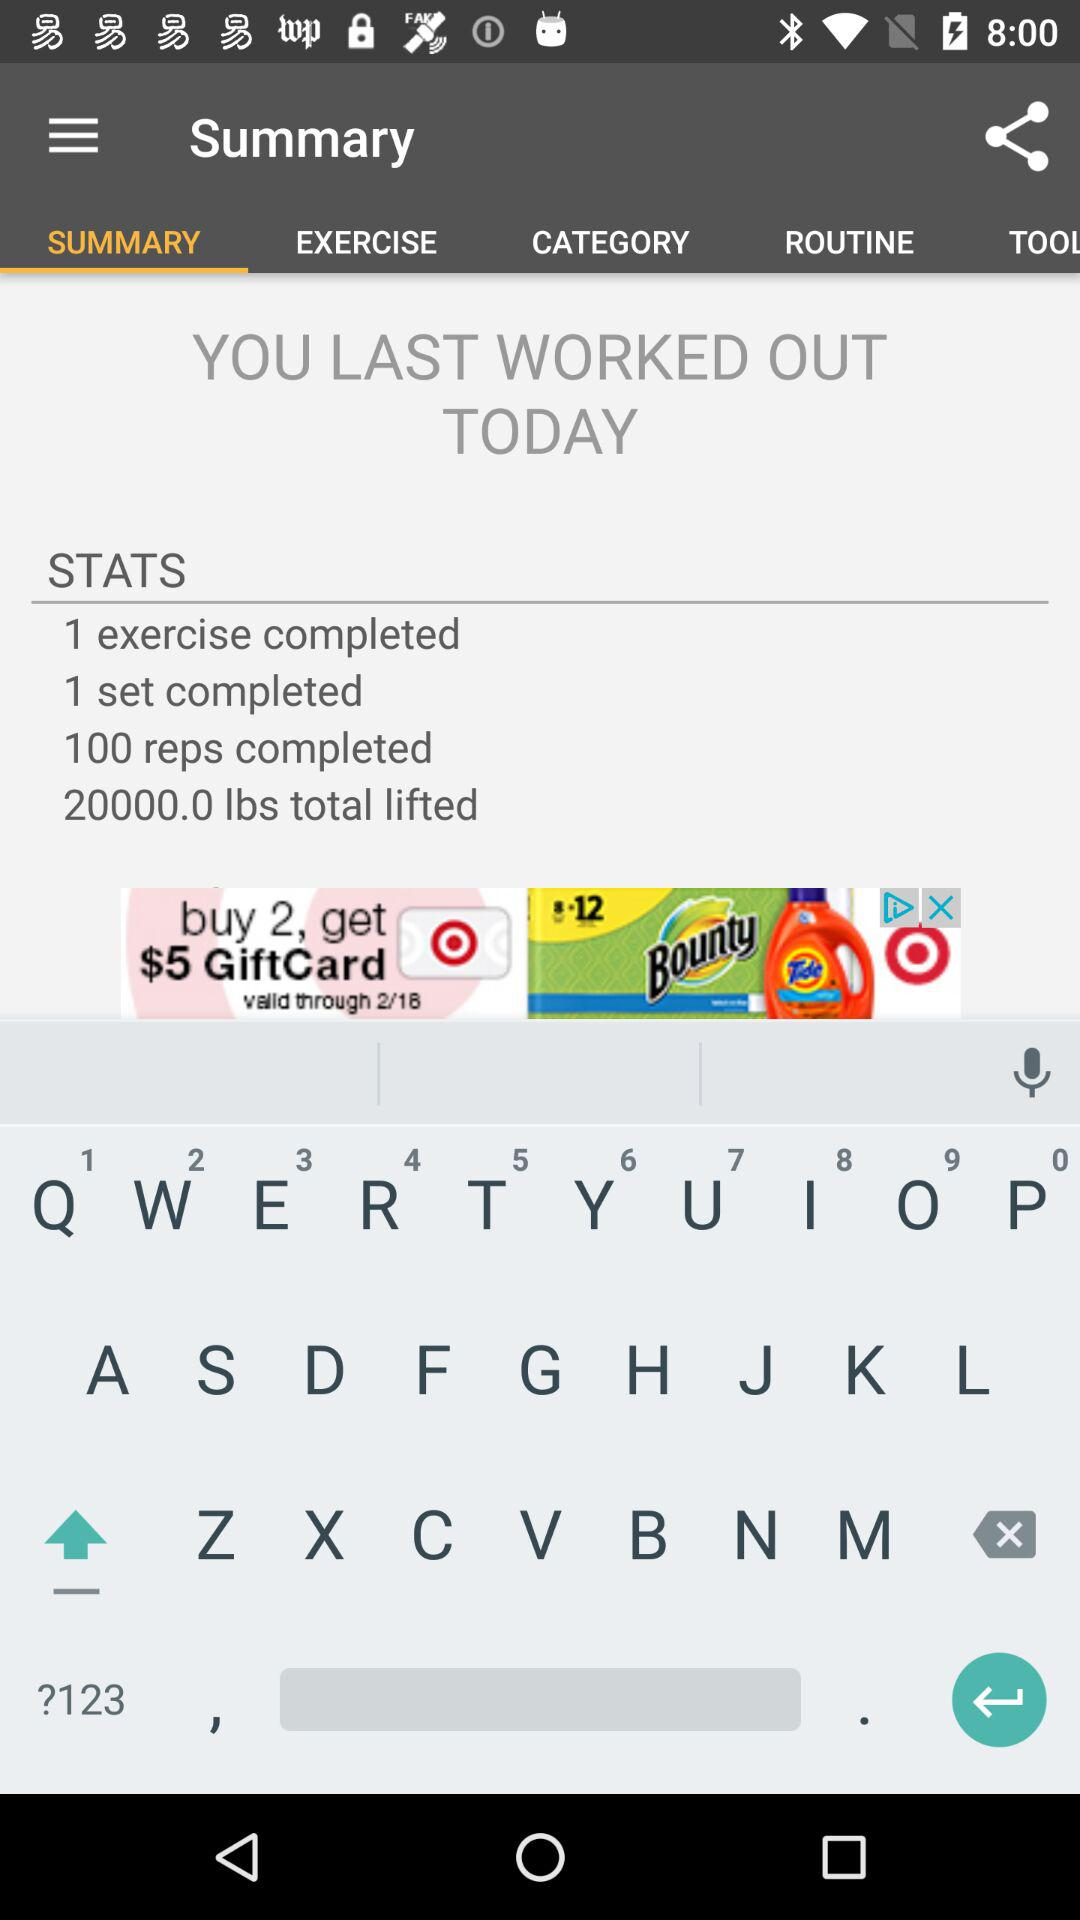How much weight did I lift in total? The workout summary on the screen indicates that you lifted a total of 20,000.0 pounds during your last session. 